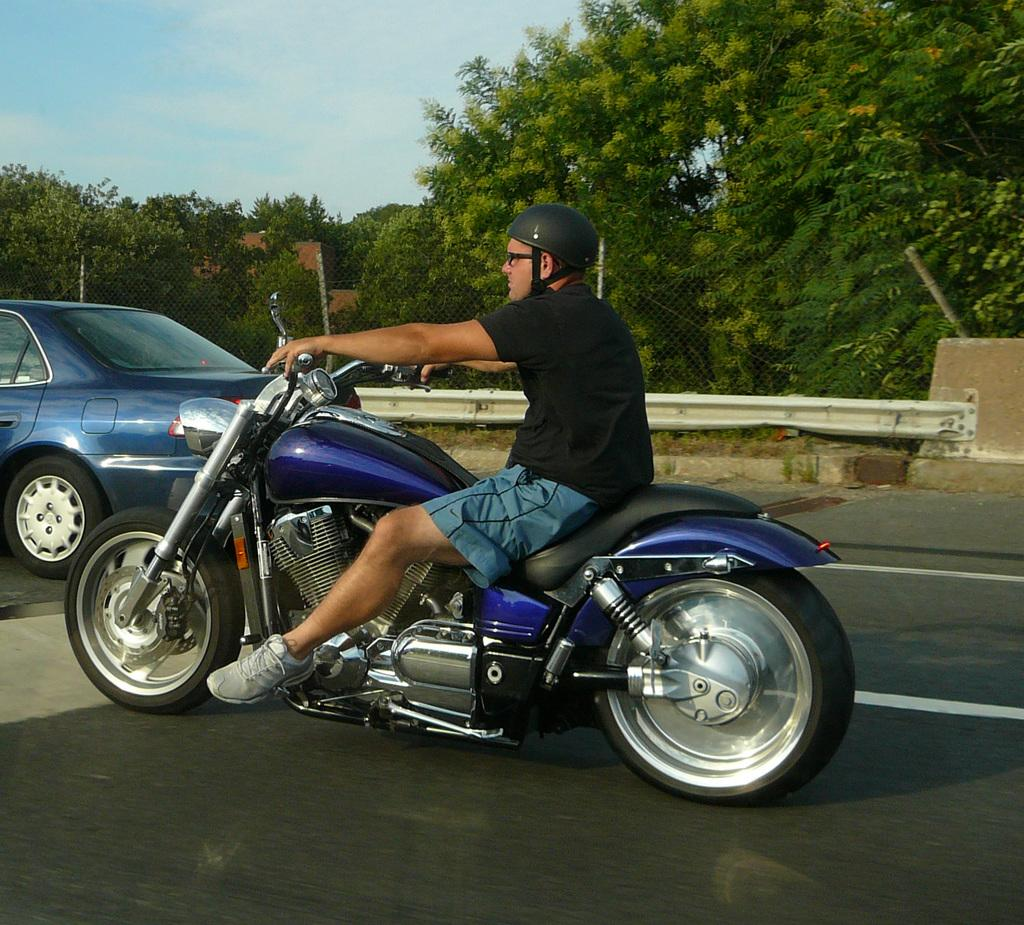What is the man in the image riding? The man is riding a motorcycle in the image. What safety gear is the man wearing? The man is wearing a helmet in the image. What other vehicle can be seen in the image? There is a car in the top left corner of the image. What type of natural scenery is visible in the background of the image? Trees are visible in the background of the image. What is the condition of the sky in the image? The sky is visible in the background of the image, and it has clouds. How much honey is the man on the motorcycle blowing into the egg in the image? There is no honey, blowing, or egg present in the image. 